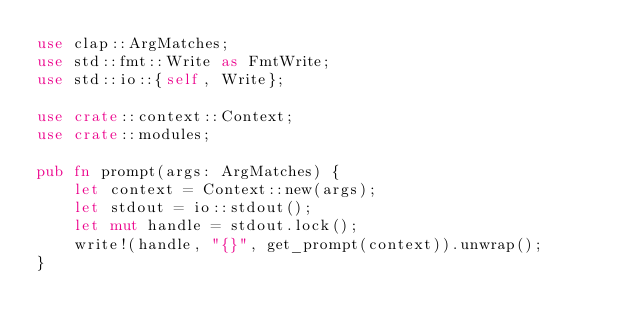Convert code to text. <code><loc_0><loc_0><loc_500><loc_500><_Rust_>use clap::ArgMatches;
use std::fmt::Write as FmtWrite;
use std::io::{self, Write};

use crate::context::Context;
use crate::modules;

pub fn prompt(args: ArgMatches) {
    let context = Context::new(args);
    let stdout = io::stdout();
    let mut handle = stdout.lock();
    write!(handle, "{}", get_prompt(context)).unwrap();
}
</code> 